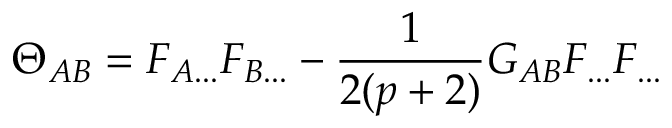Convert formula to latex. <formula><loc_0><loc_0><loc_500><loc_500>\Theta _ { A B } = F _ { A \dots } F _ { B \dots } - \frac { 1 } { 2 ( p + 2 ) } G _ { A B } F _ { \dots } F _ { \dots }</formula> 